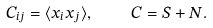Convert formula to latex. <formula><loc_0><loc_0><loc_500><loc_500>C _ { i j } = \langle x _ { i } x _ { j } \rangle , \quad C = { S } + { N } .</formula> 